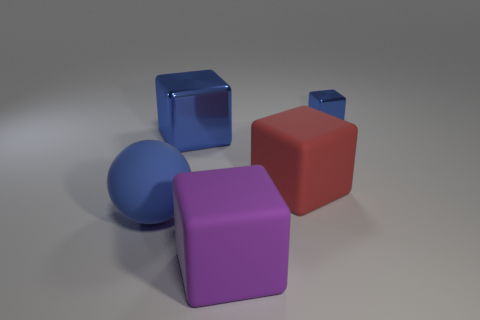Is the blue rubber thing the same shape as the large blue metallic object?
Offer a very short reply. No. What is the size of the red matte object that is the same shape as the purple matte thing?
Your response must be concise. Large. Is the number of rubber blocks behind the purple matte object greater than the number of blue metallic cubes that are in front of the large blue metal block?
Provide a short and direct response. Yes. Do the large red thing and the blue object to the right of the large red block have the same material?
Make the answer very short. No. Is there anything else that has the same shape as the blue rubber thing?
Ensure brevity in your answer.  No. What color is the object that is in front of the tiny thing and on the right side of the big purple matte object?
Provide a succinct answer. Red. There is a large matte object that is right of the large purple matte object; what is its shape?
Your answer should be compact. Cube. What is the size of the blue shiny object that is right of the purple rubber cube that is to the right of the blue metallic block that is on the left side of the small blue metallic thing?
Provide a succinct answer. Small. There is a large cube in front of the large blue rubber sphere; what number of big blue shiny things are to the right of it?
Offer a terse response. 0. How big is the thing that is behind the big red matte object and to the right of the large purple object?
Your response must be concise. Small. 